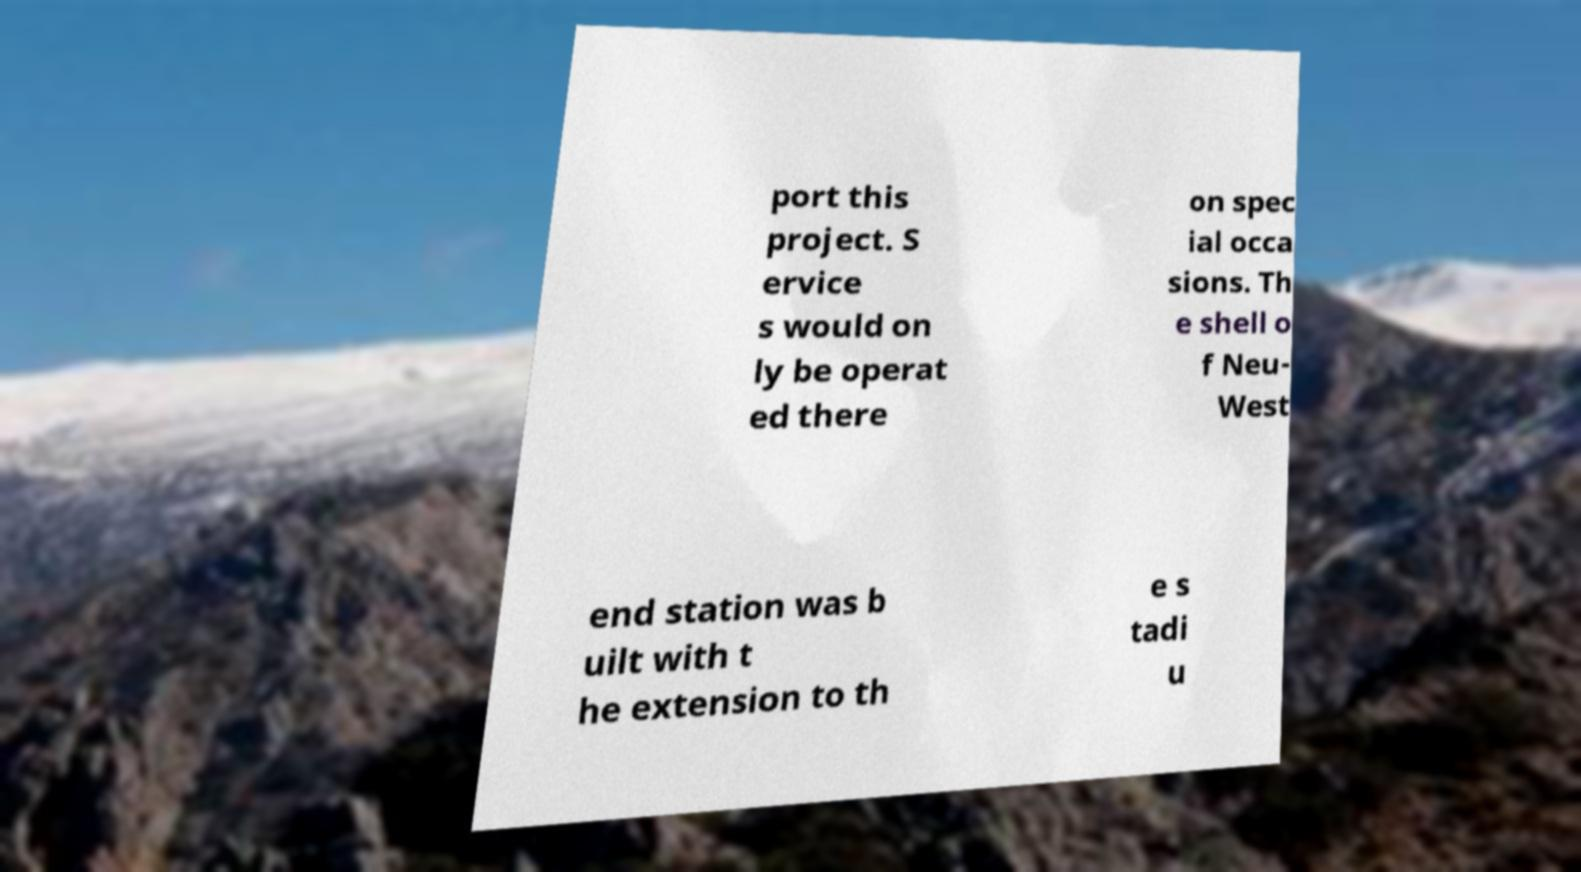Could you assist in decoding the text presented in this image and type it out clearly? port this project. S ervice s would on ly be operat ed there on spec ial occa sions. Th e shell o f Neu- West end station was b uilt with t he extension to th e s tadi u 